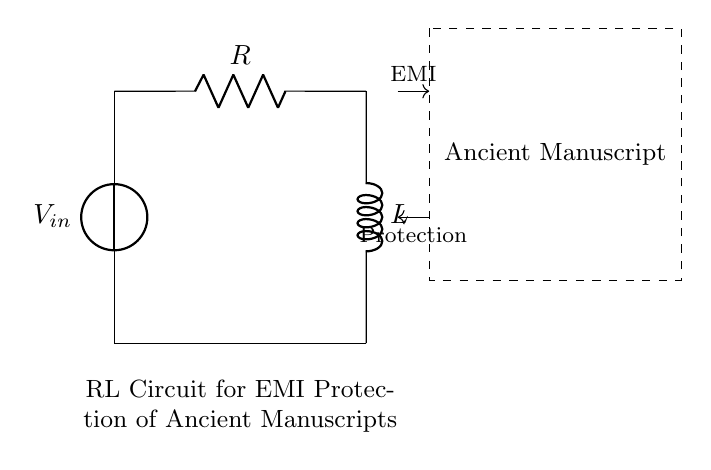What components are present in this circuit? The circuit includes a voltage source (V), a resistor (R), and an inductor (L), which are clearly labeled in the diagram.
Answer: voltage source, resistor, inductor What is the purpose of the inductor in this circuit? The inductor is used to impede changes in current, which helps reduce electromagnetic interference that could affect the ancient manuscripts.
Answer: reduce EMI How does the circuit protect the ancient manuscript? The circuit minimizes the impact of electromagnetic interference by using the combination of the resistor and inductor, which absorbs and dissipates unwanted interference.
Answer: absorbs EMI What does the dashed rectangle represent in this diagram? The dashed rectangle indicates the area containing the ancient manuscript, highlighting its importance and the need for protection from EMI.
Answer: ancient manuscript What type of circuit is depicted here? This is an RL circuit, which specifically includes a resistor and an inductor in series, commonly used for filtering and impedance purposes.
Answer: RL circuit What happens to the current when EMI is applied? The inductor resists changes in current, causing a delay or reduction in the flow of current, which helps to protect the manuscript from sudden spikes of interference.
Answer: current reduction What is the flow direction of the EMI indicated in the diagram? The flow direction of EMI is shown with an arrow pointing towards the manuscript from the voltage source, indicating interference entering the system.
Answer: towards manuscript 